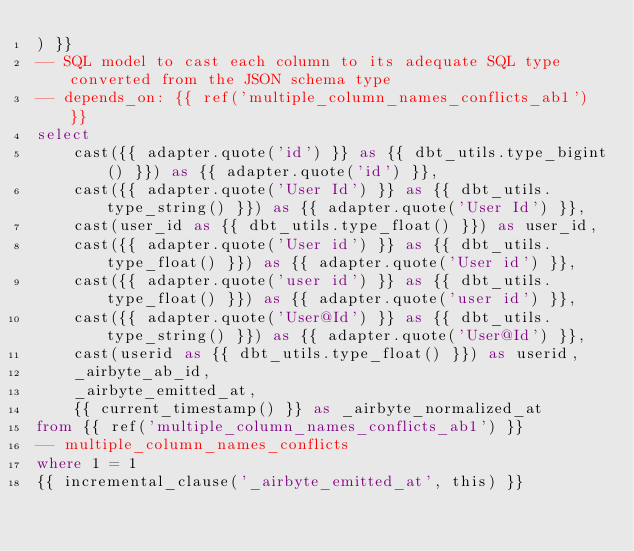<code> <loc_0><loc_0><loc_500><loc_500><_SQL_>) }}
-- SQL model to cast each column to its adequate SQL type converted from the JSON schema type
-- depends_on: {{ ref('multiple_column_names_conflicts_ab1') }}
select
    cast({{ adapter.quote('id') }} as {{ dbt_utils.type_bigint() }}) as {{ adapter.quote('id') }},
    cast({{ adapter.quote('User Id') }} as {{ dbt_utils.type_string() }}) as {{ adapter.quote('User Id') }},
    cast(user_id as {{ dbt_utils.type_float() }}) as user_id,
    cast({{ adapter.quote('User id') }} as {{ dbt_utils.type_float() }}) as {{ adapter.quote('User id') }},
    cast({{ adapter.quote('user id') }} as {{ dbt_utils.type_float() }}) as {{ adapter.quote('user id') }},
    cast({{ adapter.quote('User@Id') }} as {{ dbt_utils.type_string() }}) as {{ adapter.quote('User@Id') }},
    cast(userid as {{ dbt_utils.type_float() }}) as userid,
    _airbyte_ab_id,
    _airbyte_emitted_at,
    {{ current_timestamp() }} as _airbyte_normalized_at
from {{ ref('multiple_column_names_conflicts_ab1') }}
-- multiple_column_names_conflicts
where 1 = 1
{{ incremental_clause('_airbyte_emitted_at', this) }}

</code> 